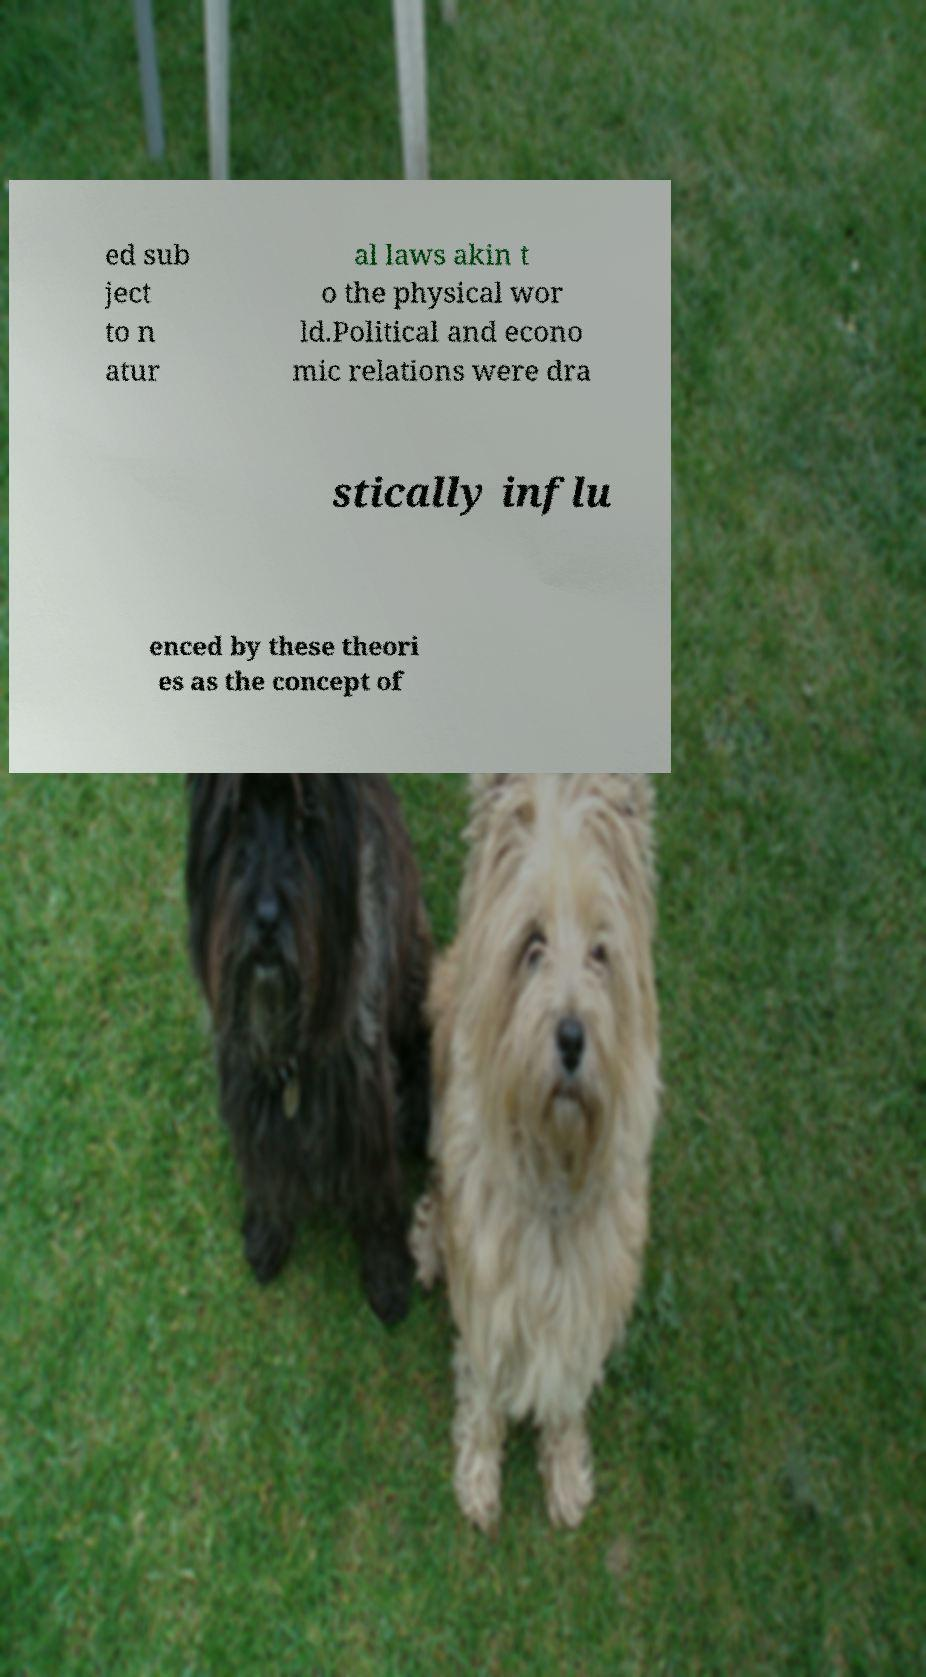For documentation purposes, I need the text within this image transcribed. Could you provide that? ed sub ject to n atur al laws akin t o the physical wor ld.Political and econo mic relations were dra stically influ enced by these theori es as the concept of 